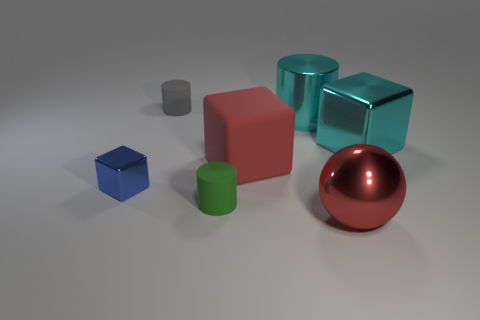Add 3 green rubber cylinders. How many objects exist? 10 Subtract all cubes. How many objects are left? 4 Subtract all tiny cyan blocks. Subtract all tiny rubber objects. How many objects are left? 5 Add 2 cylinders. How many cylinders are left? 5 Add 5 small brown matte things. How many small brown matte things exist? 5 Subtract 0 blue cylinders. How many objects are left? 7 